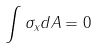<formula> <loc_0><loc_0><loc_500><loc_500>\int \sigma _ { x } d A = 0</formula> 